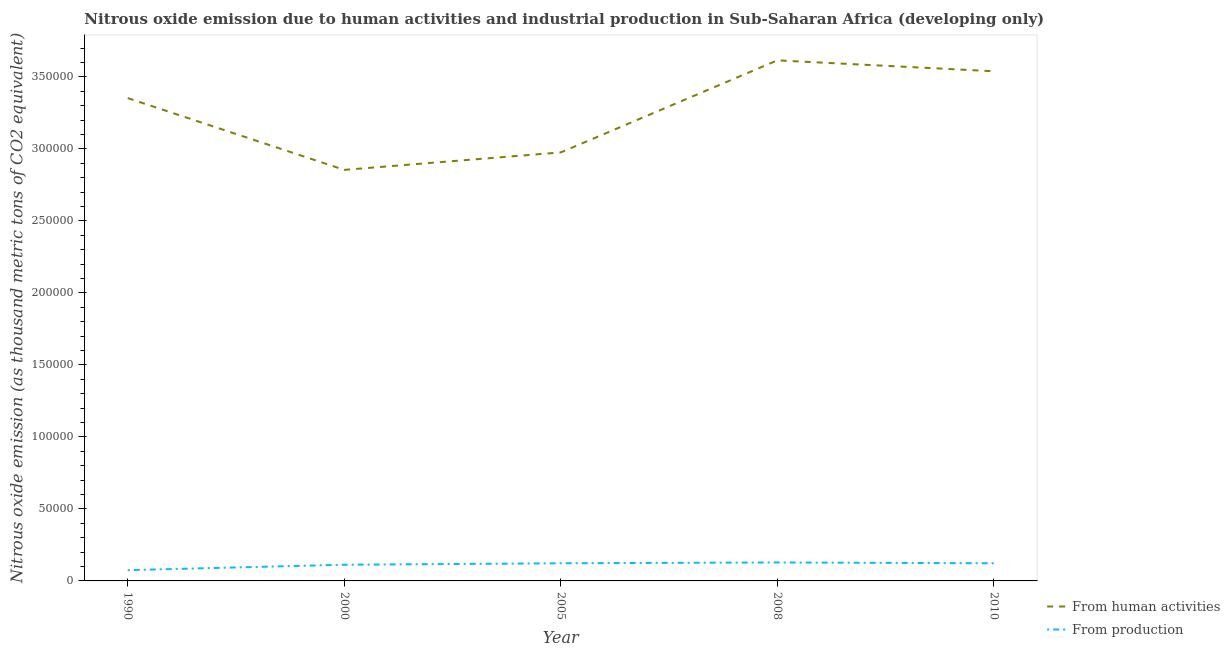How many different coloured lines are there?
Make the answer very short. 2. Does the line corresponding to amount of emissions generated from industries intersect with the line corresponding to amount of emissions from human activities?
Make the answer very short. No. Is the number of lines equal to the number of legend labels?
Ensure brevity in your answer.  Yes. What is the amount of emissions generated from industries in 2005?
Make the answer very short. 1.23e+04. Across all years, what is the maximum amount of emissions from human activities?
Give a very brief answer. 3.61e+05. Across all years, what is the minimum amount of emissions from human activities?
Provide a short and direct response. 2.85e+05. In which year was the amount of emissions generated from industries maximum?
Provide a succinct answer. 2008. What is the total amount of emissions from human activities in the graph?
Offer a terse response. 1.63e+06. What is the difference between the amount of emissions from human activities in 1990 and that in 2000?
Your response must be concise. 4.98e+04. What is the difference between the amount of emissions generated from industries in 2008 and the amount of emissions from human activities in 1990?
Ensure brevity in your answer.  -3.22e+05. What is the average amount of emissions generated from industries per year?
Provide a succinct answer. 1.12e+04. In the year 2005, what is the difference between the amount of emissions from human activities and amount of emissions generated from industries?
Provide a short and direct response. 2.85e+05. What is the ratio of the amount of emissions from human activities in 2000 to that in 2005?
Provide a short and direct response. 0.96. What is the difference between the highest and the second highest amount of emissions generated from industries?
Provide a short and direct response. 576.6. What is the difference between the highest and the lowest amount of emissions from human activities?
Provide a short and direct response. 7.60e+04. In how many years, is the amount of emissions from human activities greater than the average amount of emissions from human activities taken over all years?
Offer a very short reply. 3. Is the amount of emissions from human activities strictly less than the amount of emissions generated from industries over the years?
Provide a succinct answer. No. How many lines are there?
Your answer should be compact. 2. Does the graph contain grids?
Your answer should be very brief. No. Where does the legend appear in the graph?
Your answer should be compact. Bottom right. How are the legend labels stacked?
Keep it short and to the point. Vertical. What is the title of the graph?
Your response must be concise. Nitrous oxide emission due to human activities and industrial production in Sub-Saharan Africa (developing only). What is the label or title of the Y-axis?
Give a very brief answer. Nitrous oxide emission (as thousand metric tons of CO2 equivalent). What is the Nitrous oxide emission (as thousand metric tons of CO2 equivalent) of From human activities in 1990?
Your response must be concise. 3.35e+05. What is the Nitrous oxide emission (as thousand metric tons of CO2 equivalent) in From production in 1990?
Make the answer very short. 7482.3. What is the Nitrous oxide emission (as thousand metric tons of CO2 equivalent) in From human activities in 2000?
Provide a short and direct response. 2.85e+05. What is the Nitrous oxide emission (as thousand metric tons of CO2 equivalent) of From production in 2000?
Your answer should be very brief. 1.12e+04. What is the Nitrous oxide emission (as thousand metric tons of CO2 equivalent) of From human activities in 2005?
Keep it short and to the point. 2.98e+05. What is the Nitrous oxide emission (as thousand metric tons of CO2 equivalent) in From production in 2005?
Your answer should be compact. 1.23e+04. What is the Nitrous oxide emission (as thousand metric tons of CO2 equivalent) in From human activities in 2008?
Your answer should be very brief. 3.61e+05. What is the Nitrous oxide emission (as thousand metric tons of CO2 equivalent) of From production in 2008?
Keep it short and to the point. 1.28e+04. What is the Nitrous oxide emission (as thousand metric tons of CO2 equivalent) of From human activities in 2010?
Offer a terse response. 3.54e+05. What is the Nitrous oxide emission (as thousand metric tons of CO2 equivalent) of From production in 2010?
Provide a short and direct response. 1.22e+04. Across all years, what is the maximum Nitrous oxide emission (as thousand metric tons of CO2 equivalent) in From human activities?
Keep it short and to the point. 3.61e+05. Across all years, what is the maximum Nitrous oxide emission (as thousand metric tons of CO2 equivalent) of From production?
Your response must be concise. 1.28e+04. Across all years, what is the minimum Nitrous oxide emission (as thousand metric tons of CO2 equivalent) in From human activities?
Provide a succinct answer. 2.85e+05. Across all years, what is the minimum Nitrous oxide emission (as thousand metric tons of CO2 equivalent) of From production?
Offer a terse response. 7482.3. What is the total Nitrous oxide emission (as thousand metric tons of CO2 equivalent) of From human activities in the graph?
Offer a very short reply. 1.63e+06. What is the total Nitrous oxide emission (as thousand metric tons of CO2 equivalent) of From production in the graph?
Provide a short and direct response. 5.61e+04. What is the difference between the Nitrous oxide emission (as thousand metric tons of CO2 equivalent) in From human activities in 1990 and that in 2000?
Your answer should be compact. 4.98e+04. What is the difference between the Nitrous oxide emission (as thousand metric tons of CO2 equivalent) in From production in 1990 and that in 2000?
Your response must be concise. -3756.4. What is the difference between the Nitrous oxide emission (as thousand metric tons of CO2 equivalent) of From human activities in 1990 and that in 2005?
Offer a terse response. 3.77e+04. What is the difference between the Nitrous oxide emission (as thousand metric tons of CO2 equivalent) in From production in 1990 and that in 2005?
Provide a succinct answer. -4774.5. What is the difference between the Nitrous oxide emission (as thousand metric tons of CO2 equivalent) of From human activities in 1990 and that in 2008?
Provide a short and direct response. -2.62e+04. What is the difference between the Nitrous oxide emission (as thousand metric tons of CO2 equivalent) in From production in 1990 and that in 2008?
Provide a short and direct response. -5351.1. What is the difference between the Nitrous oxide emission (as thousand metric tons of CO2 equivalent) of From human activities in 1990 and that in 2010?
Give a very brief answer. -1.86e+04. What is the difference between the Nitrous oxide emission (as thousand metric tons of CO2 equivalent) in From production in 1990 and that in 2010?
Give a very brief answer. -4759.9. What is the difference between the Nitrous oxide emission (as thousand metric tons of CO2 equivalent) in From human activities in 2000 and that in 2005?
Offer a very short reply. -1.21e+04. What is the difference between the Nitrous oxide emission (as thousand metric tons of CO2 equivalent) of From production in 2000 and that in 2005?
Your response must be concise. -1018.1. What is the difference between the Nitrous oxide emission (as thousand metric tons of CO2 equivalent) of From human activities in 2000 and that in 2008?
Your response must be concise. -7.60e+04. What is the difference between the Nitrous oxide emission (as thousand metric tons of CO2 equivalent) in From production in 2000 and that in 2008?
Give a very brief answer. -1594.7. What is the difference between the Nitrous oxide emission (as thousand metric tons of CO2 equivalent) of From human activities in 2000 and that in 2010?
Ensure brevity in your answer.  -6.85e+04. What is the difference between the Nitrous oxide emission (as thousand metric tons of CO2 equivalent) of From production in 2000 and that in 2010?
Ensure brevity in your answer.  -1003.5. What is the difference between the Nitrous oxide emission (as thousand metric tons of CO2 equivalent) of From human activities in 2005 and that in 2008?
Keep it short and to the point. -6.39e+04. What is the difference between the Nitrous oxide emission (as thousand metric tons of CO2 equivalent) in From production in 2005 and that in 2008?
Ensure brevity in your answer.  -576.6. What is the difference between the Nitrous oxide emission (as thousand metric tons of CO2 equivalent) of From human activities in 2005 and that in 2010?
Ensure brevity in your answer.  -5.63e+04. What is the difference between the Nitrous oxide emission (as thousand metric tons of CO2 equivalent) in From human activities in 2008 and that in 2010?
Your response must be concise. 7568.3. What is the difference between the Nitrous oxide emission (as thousand metric tons of CO2 equivalent) of From production in 2008 and that in 2010?
Keep it short and to the point. 591.2. What is the difference between the Nitrous oxide emission (as thousand metric tons of CO2 equivalent) of From human activities in 1990 and the Nitrous oxide emission (as thousand metric tons of CO2 equivalent) of From production in 2000?
Provide a short and direct response. 3.24e+05. What is the difference between the Nitrous oxide emission (as thousand metric tons of CO2 equivalent) of From human activities in 1990 and the Nitrous oxide emission (as thousand metric tons of CO2 equivalent) of From production in 2005?
Make the answer very short. 3.23e+05. What is the difference between the Nitrous oxide emission (as thousand metric tons of CO2 equivalent) of From human activities in 1990 and the Nitrous oxide emission (as thousand metric tons of CO2 equivalent) of From production in 2008?
Keep it short and to the point. 3.22e+05. What is the difference between the Nitrous oxide emission (as thousand metric tons of CO2 equivalent) of From human activities in 1990 and the Nitrous oxide emission (as thousand metric tons of CO2 equivalent) of From production in 2010?
Ensure brevity in your answer.  3.23e+05. What is the difference between the Nitrous oxide emission (as thousand metric tons of CO2 equivalent) of From human activities in 2000 and the Nitrous oxide emission (as thousand metric tons of CO2 equivalent) of From production in 2005?
Ensure brevity in your answer.  2.73e+05. What is the difference between the Nitrous oxide emission (as thousand metric tons of CO2 equivalent) in From human activities in 2000 and the Nitrous oxide emission (as thousand metric tons of CO2 equivalent) in From production in 2008?
Your response must be concise. 2.73e+05. What is the difference between the Nitrous oxide emission (as thousand metric tons of CO2 equivalent) in From human activities in 2000 and the Nitrous oxide emission (as thousand metric tons of CO2 equivalent) in From production in 2010?
Your answer should be compact. 2.73e+05. What is the difference between the Nitrous oxide emission (as thousand metric tons of CO2 equivalent) of From human activities in 2005 and the Nitrous oxide emission (as thousand metric tons of CO2 equivalent) of From production in 2008?
Keep it short and to the point. 2.85e+05. What is the difference between the Nitrous oxide emission (as thousand metric tons of CO2 equivalent) in From human activities in 2005 and the Nitrous oxide emission (as thousand metric tons of CO2 equivalent) in From production in 2010?
Your answer should be very brief. 2.85e+05. What is the difference between the Nitrous oxide emission (as thousand metric tons of CO2 equivalent) of From human activities in 2008 and the Nitrous oxide emission (as thousand metric tons of CO2 equivalent) of From production in 2010?
Ensure brevity in your answer.  3.49e+05. What is the average Nitrous oxide emission (as thousand metric tons of CO2 equivalent) in From human activities per year?
Offer a very short reply. 3.27e+05. What is the average Nitrous oxide emission (as thousand metric tons of CO2 equivalent) in From production per year?
Give a very brief answer. 1.12e+04. In the year 1990, what is the difference between the Nitrous oxide emission (as thousand metric tons of CO2 equivalent) of From human activities and Nitrous oxide emission (as thousand metric tons of CO2 equivalent) of From production?
Keep it short and to the point. 3.28e+05. In the year 2000, what is the difference between the Nitrous oxide emission (as thousand metric tons of CO2 equivalent) in From human activities and Nitrous oxide emission (as thousand metric tons of CO2 equivalent) in From production?
Give a very brief answer. 2.74e+05. In the year 2005, what is the difference between the Nitrous oxide emission (as thousand metric tons of CO2 equivalent) of From human activities and Nitrous oxide emission (as thousand metric tons of CO2 equivalent) of From production?
Your answer should be compact. 2.85e+05. In the year 2008, what is the difference between the Nitrous oxide emission (as thousand metric tons of CO2 equivalent) of From human activities and Nitrous oxide emission (as thousand metric tons of CO2 equivalent) of From production?
Your answer should be compact. 3.49e+05. In the year 2010, what is the difference between the Nitrous oxide emission (as thousand metric tons of CO2 equivalent) in From human activities and Nitrous oxide emission (as thousand metric tons of CO2 equivalent) in From production?
Offer a terse response. 3.42e+05. What is the ratio of the Nitrous oxide emission (as thousand metric tons of CO2 equivalent) in From human activities in 1990 to that in 2000?
Offer a very short reply. 1.17. What is the ratio of the Nitrous oxide emission (as thousand metric tons of CO2 equivalent) in From production in 1990 to that in 2000?
Keep it short and to the point. 0.67. What is the ratio of the Nitrous oxide emission (as thousand metric tons of CO2 equivalent) in From human activities in 1990 to that in 2005?
Your answer should be very brief. 1.13. What is the ratio of the Nitrous oxide emission (as thousand metric tons of CO2 equivalent) of From production in 1990 to that in 2005?
Keep it short and to the point. 0.61. What is the ratio of the Nitrous oxide emission (as thousand metric tons of CO2 equivalent) in From human activities in 1990 to that in 2008?
Keep it short and to the point. 0.93. What is the ratio of the Nitrous oxide emission (as thousand metric tons of CO2 equivalent) of From production in 1990 to that in 2008?
Ensure brevity in your answer.  0.58. What is the ratio of the Nitrous oxide emission (as thousand metric tons of CO2 equivalent) of From human activities in 1990 to that in 2010?
Provide a succinct answer. 0.95. What is the ratio of the Nitrous oxide emission (as thousand metric tons of CO2 equivalent) in From production in 1990 to that in 2010?
Your answer should be compact. 0.61. What is the ratio of the Nitrous oxide emission (as thousand metric tons of CO2 equivalent) of From human activities in 2000 to that in 2005?
Offer a terse response. 0.96. What is the ratio of the Nitrous oxide emission (as thousand metric tons of CO2 equivalent) in From production in 2000 to that in 2005?
Provide a short and direct response. 0.92. What is the ratio of the Nitrous oxide emission (as thousand metric tons of CO2 equivalent) in From human activities in 2000 to that in 2008?
Keep it short and to the point. 0.79. What is the ratio of the Nitrous oxide emission (as thousand metric tons of CO2 equivalent) in From production in 2000 to that in 2008?
Your answer should be compact. 0.88. What is the ratio of the Nitrous oxide emission (as thousand metric tons of CO2 equivalent) of From human activities in 2000 to that in 2010?
Your response must be concise. 0.81. What is the ratio of the Nitrous oxide emission (as thousand metric tons of CO2 equivalent) in From production in 2000 to that in 2010?
Your answer should be very brief. 0.92. What is the ratio of the Nitrous oxide emission (as thousand metric tons of CO2 equivalent) of From human activities in 2005 to that in 2008?
Your answer should be compact. 0.82. What is the ratio of the Nitrous oxide emission (as thousand metric tons of CO2 equivalent) of From production in 2005 to that in 2008?
Your answer should be very brief. 0.96. What is the ratio of the Nitrous oxide emission (as thousand metric tons of CO2 equivalent) of From human activities in 2005 to that in 2010?
Give a very brief answer. 0.84. What is the ratio of the Nitrous oxide emission (as thousand metric tons of CO2 equivalent) of From human activities in 2008 to that in 2010?
Your answer should be very brief. 1.02. What is the ratio of the Nitrous oxide emission (as thousand metric tons of CO2 equivalent) of From production in 2008 to that in 2010?
Make the answer very short. 1.05. What is the difference between the highest and the second highest Nitrous oxide emission (as thousand metric tons of CO2 equivalent) in From human activities?
Offer a terse response. 7568.3. What is the difference between the highest and the second highest Nitrous oxide emission (as thousand metric tons of CO2 equivalent) of From production?
Give a very brief answer. 576.6. What is the difference between the highest and the lowest Nitrous oxide emission (as thousand metric tons of CO2 equivalent) of From human activities?
Your response must be concise. 7.60e+04. What is the difference between the highest and the lowest Nitrous oxide emission (as thousand metric tons of CO2 equivalent) in From production?
Your answer should be compact. 5351.1. 